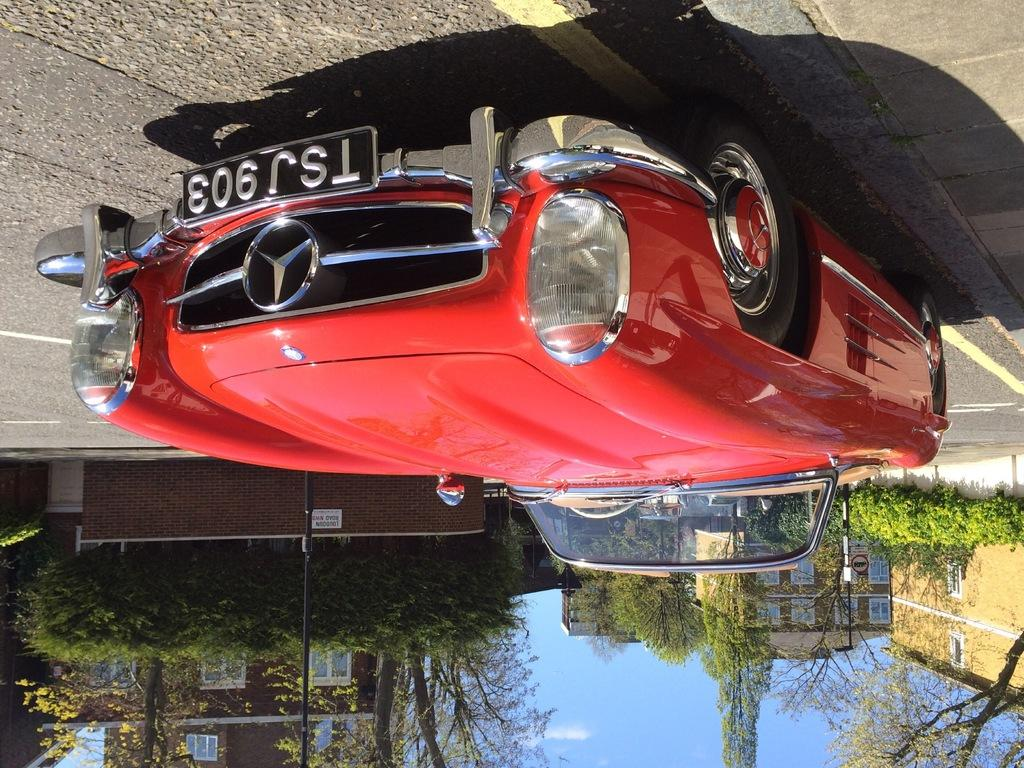What is the main subject of the image? There is a car on the road in the image. What else can be seen in the background of the image? There are buildings and trees visible in the image. Where is the vase located in the image? There is no vase present in the image. What type of frog can be seen hopping on the car in the image? There is no frog present in the image, and the car is stationary on the road. 